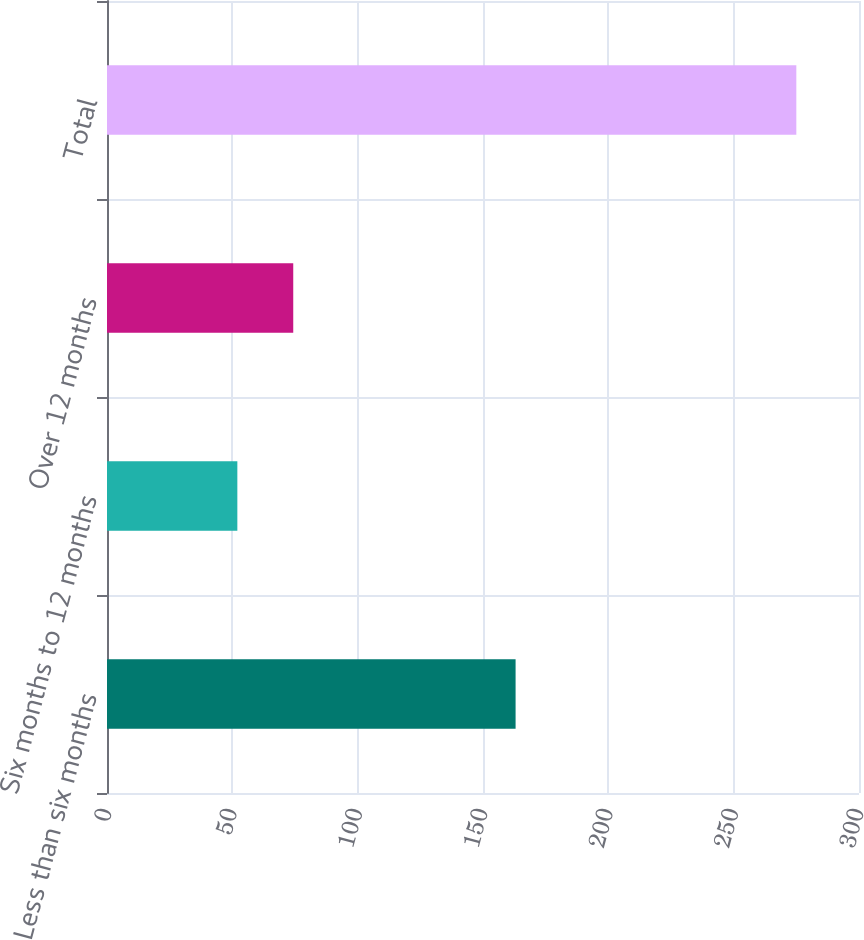Convert chart to OTSL. <chart><loc_0><loc_0><loc_500><loc_500><bar_chart><fcel>Less than six months<fcel>Six months to 12 months<fcel>Over 12 months<fcel>Total<nl><fcel>163<fcel>52<fcel>74.3<fcel>275<nl></chart> 